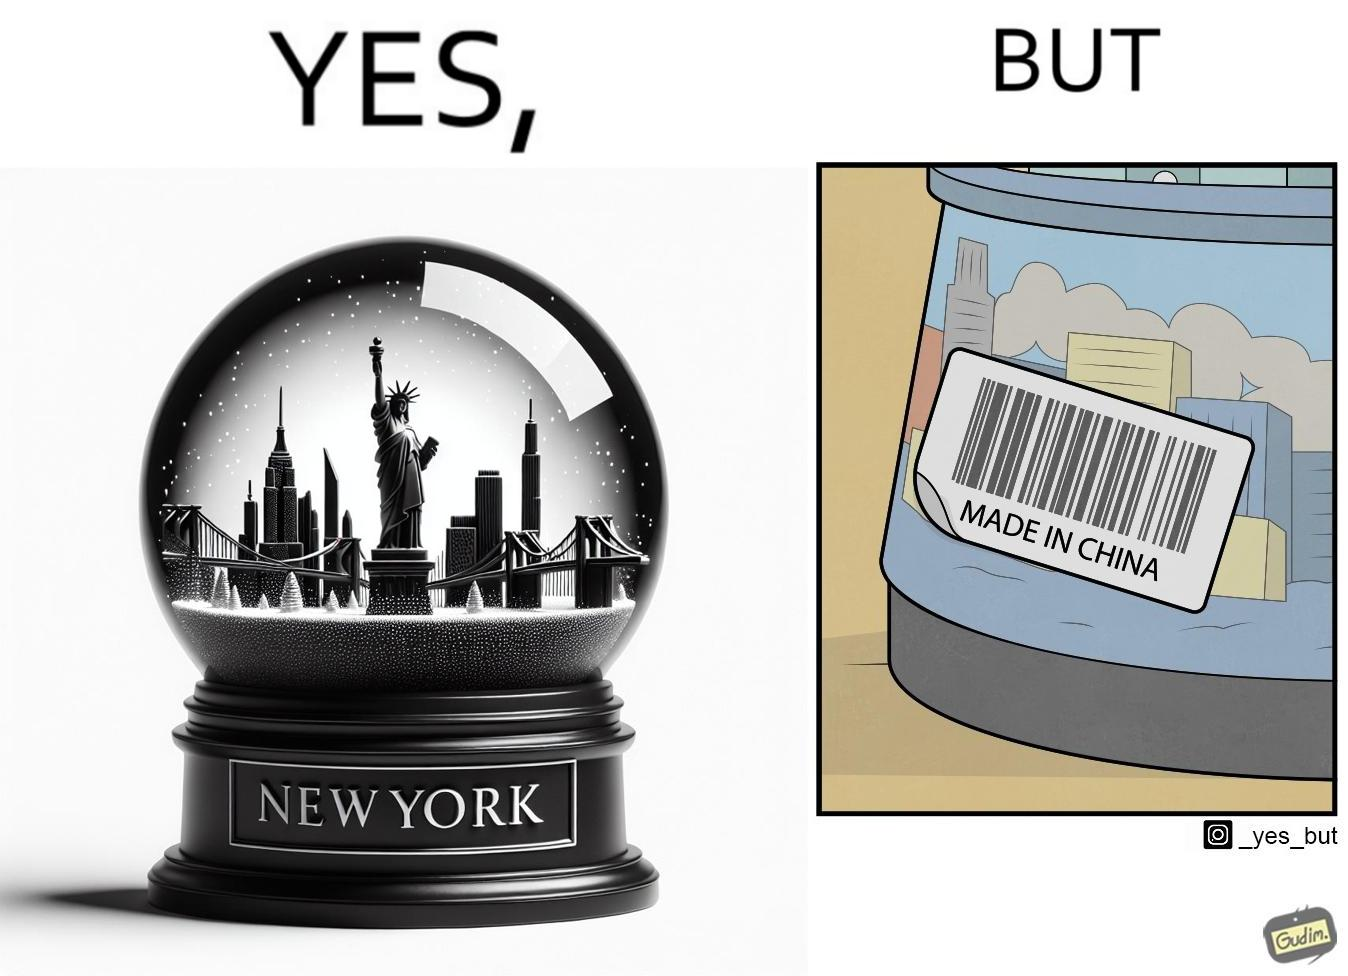Is this a satirical image? Yes, this image is satirical. 